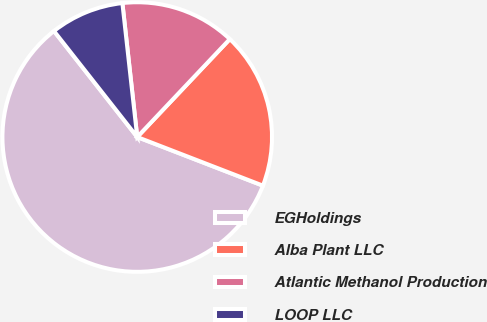<chart> <loc_0><loc_0><loc_500><loc_500><pie_chart><fcel>EGHoldings<fcel>Alba Plant LLC<fcel>Atlantic Methanol Production<fcel>LOOP LLC<nl><fcel>58.53%<fcel>18.82%<fcel>13.81%<fcel>8.84%<nl></chart> 